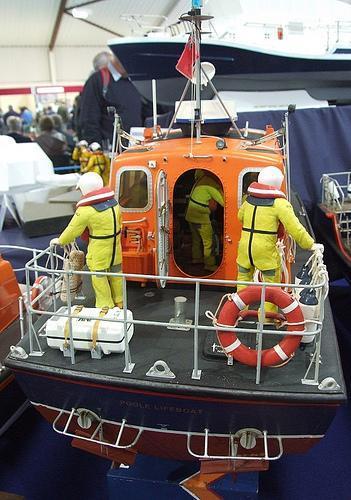How many people are on the boat?
Give a very brief answer. 3. How many people are on the boat?
Give a very brief answer. 3. How many people are in the picture?
Give a very brief answer. 4. 